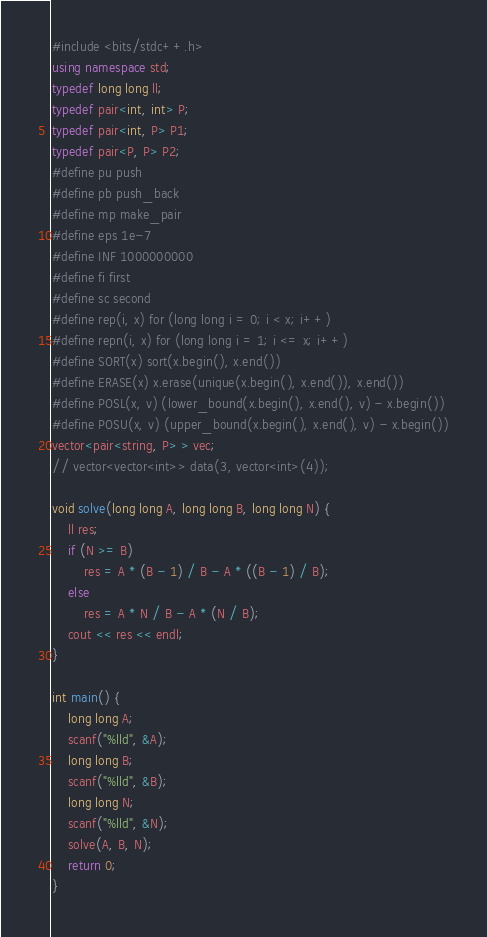Convert code to text. <code><loc_0><loc_0><loc_500><loc_500><_C++_>#include <bits/stdc++.h>
using namespace std;
typedef long long ll;
typedef pair<int, int> P;
typedef pair<int, P> P1;
typedef pair<P, P> P2;
#define pu push
#define pb push_back
#define mp make_pair
#define eps 1e-7
#define INF 1000000000
#define fi first
#define sc second
#define rep(i, x) for (long long i = 0; i < x; i++)
#define repn(i, x) for (long long i = 1; i <= x; i++)
#define SORT(x) sort(x.begin(), x.end())
#define ERASE(x) x.erase(unique(x.begin(), x.end()), x.end())
#define POSL(x, v) (lower_bound(x.begin(), x.end(), v) - x.begin())
#define POSU(x, v) (upper_bound(x.begin(), x.end(), v) - x.begin())
vector<pair<string, P> > vec;
// vector<vector<int>> data(3, vector<int>(4));

void solve(long long A, long long B, long long N) {
    ll res;
    if (N >= B)
        res = A * (B - 1) / B - A * ((B - 1) / B);
    else
        res = A * N / B - A * (N / B);
    cout << res << endl;
}

int main() {
    long long A;
    scanf("%lld", &A);
    long long B;
    scanf("%lld", &B);
    long long N;
    scanf("%lld", &N);
    solve(A, B, N);
    return 0;
}
</code> 